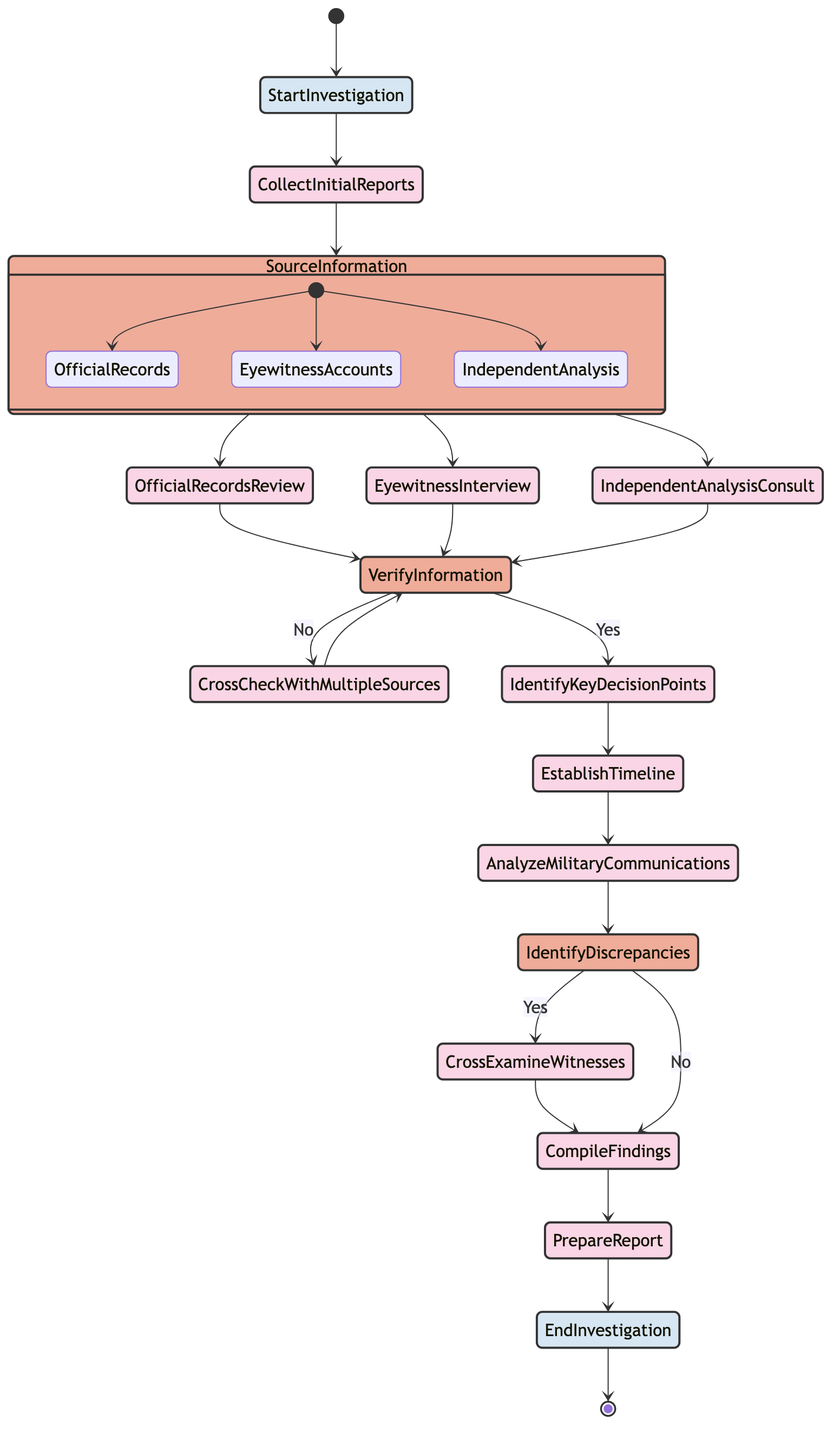What is the first activity in the diagram? The first activity in the diagram is "Start Investigation," which is indicated as the starting point before any actions take place.
Answer: Start Investigation How many decision points are there in the diagram? The diagram contains three decision points: "Source Information," "Verify Information," and "Identify Discrepancies." Each of these points allows for branching based on specific conditions.
Answer: 3 What activity follows "Eyewitness Interview"? After "Eyewitness Interview," the next step is "Verify Information," which is a decision node where the information gathered is checked for accuracy.
Answer: Verify Information What happens if "Verify Information" is answered with "No"? If "Verify Information" is answered with "No," the process goes to "Cross-Check with Multiple Sources." This step allows for further verification before the process can proceed.
Answer: Cross-Check with Multiple Sources Which activities can come from the decision node "Source Information"? From the "Source Information" decision node, three activities can follow: "Official Records Review," "Eyewitness Interview," and "Independent Analysis Consult." Each choice determines the next step of the investigation.
Answer: Official Records Review, Eyewitness Interview, Independent Analysis Consult If "Identify Discrepancies" is answered with "Yes," what is the next activity? If "Identify Discrepancies" is answered with "Yes," the next activity is "Cross-Examine Witnesses," which suggests that further investigation is warranted based on identified discrepancies.
Answer: Cross-Examine Witnesses What is the last activity before the investigation ends? The last activity before the investigation ends is "Prepare Report," where the findings are compiled and documented, leading to the conclusion of the investigation.
Answer: Prepare Report What is the outcome if "Verify Information" is answered with "Yes"? If "Verify Information" is answered with "Yes," the investigation proceeds to "Identify Key Decision Points," which is crucial for establishing the timeline and analyzing further actions taken during the military engagements.
Answer: Identify Key Decision Points After "Compile Findings," what is the next step? After "Compile Findings," the next step is "Prepare Report," where all findings are organized and documented for any subsequent analysis or publication.
Answer: Prepare Report 